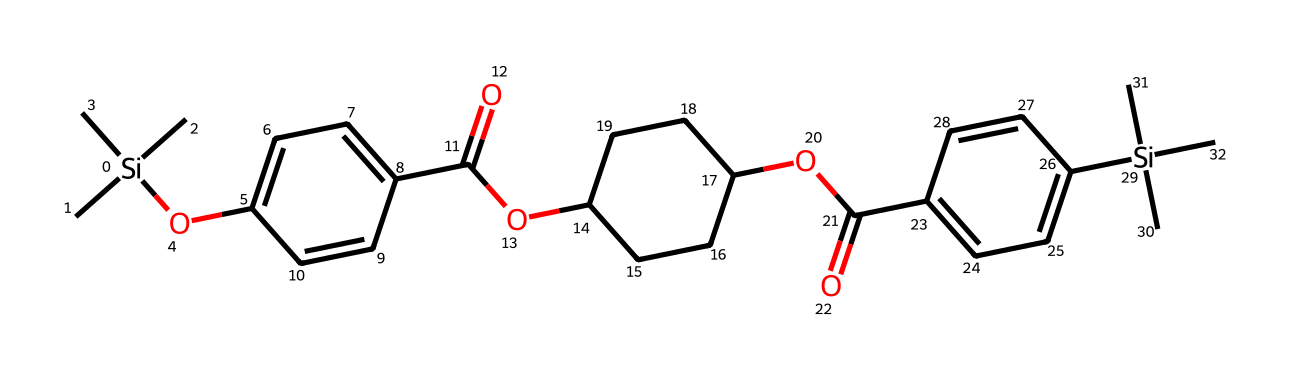What is the main silicon compound in this structure? The SMILES representation includes the silicon atom denoted by [Si], indicating that the main silicon compound is an organosilicon compound.
Answer: organosilicon How many carbon atoms are present in the structure? By counting the 'C' symbols in the SMILES, there are a total of 22 carbon atoms connected to the silicon and other groups.
Answer: 22 What functional groups can be identified from the chemical structure? The SMILES shows two ester groups (C=O and OC) and aromatic rings (C=C), indicating the presence of esters and aromatic compounds.
Answer: esters and aromatic compounds What type of bonding is predominantly found in organosilicon compounds like this? Organosilicon compounds predominantly feature covalent bonding, especially between silicon and carbon atoms shown in the structure.
Answer: covalent bonding How many rings are present in the chemical structure? There are three aromatic rings in the chemical as indicated by the presence of multiple 'C=C' bonds in the SMILES.
Answer: 3 What is the role of the siloxane groups in this compound? Siloxane groups (Si-R) in organosilicon compounds improve thermal stability, flexibility, and hydrophobic properties, which can enhance performance in electronics.
Answer: improve performance 